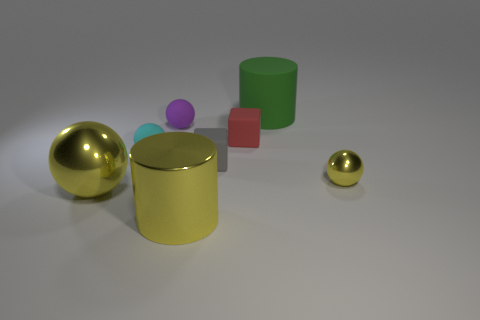Is there any other thing that has the same size as the cyan matte ball?
Ensure brevity in your answer.  Yes. Are there any green objects to the left of the red block?
Make the answer very short. No. The sphere that is on the right side of the cylinder in front of the large yellow thing left of the purple sphere is what color?
Ensure brevity in your answer.  Yellow. There is a red object that is the same size as the gray rubber thing; what shape is it?
Ensure brevity in your answer.  Cube. Is the number of small purple objects greater than the number of tiny rubber spheres?
Give a very brief answer. No. There is a yellow metallic sphere on the left side of the large shiny cylinder; is there a tiny metallic ball that is in front of it?
Keep it short and to the point. No. The other tiny matte thing that is the same shape as the small purple rubber object is what color?
Give a very brief answer. Cyan. Is there any other thing that has the same shape as the tiny cyan rubber object?
Make the answer very short. Yes. There is a tiny ball that is made of the same material as the cyan object; what is its color?
Ensure brevity in your answer.  Purple. There is a cube that is right of the small rubber thing that is in front of the small cyan rubber sphere; are there any small yellow objects that are in front of it?
Provide a succinct answer. Yes. 